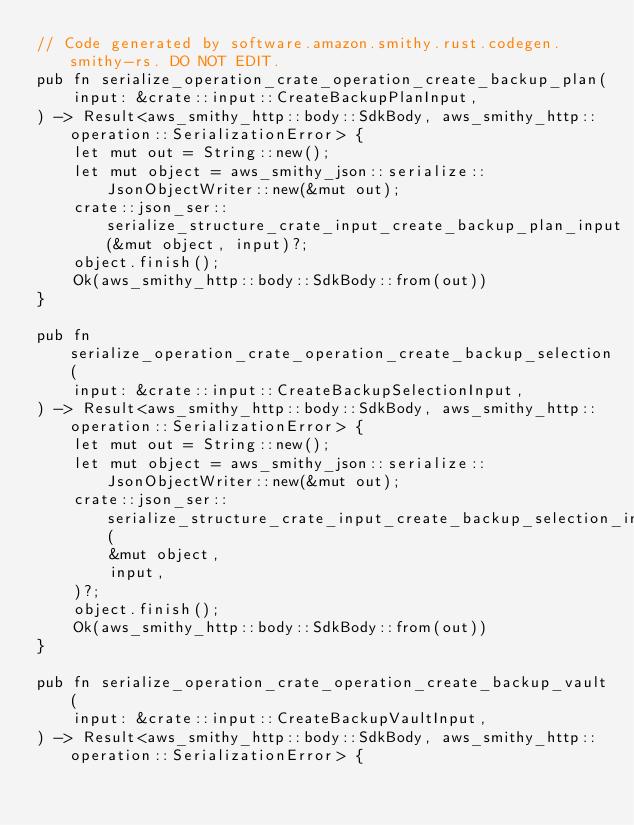<code> <loc_0><loc_0><loc_500><loc_500><_Rust_>// Code generated by software.amazon.smithy.rust.codegen.smithy-rs. DO NOT EDIT.
pub fn serialize_operation_crate_operation_create_backup_plan(
    input: &crate::input::CreateBackupPlanInput,
) -> Result<aws_smithy_http::body::SdkBody, aws_smithy_http::operation::SerializationError> {
    let mut out = String::new();
    let mut object = aws_smithy_json::serialize::JsonObjectWriter::new(&mut out);
    crate::json_ser::serialize_structure_crate_input_create_backup_plan_input(&mut object, input)?;
    object.finish();
    Ok(aws_smithy_http::body::SdkBody::from(out))
}

pub fn serialize_operation_crate_operation_create_backup_selection(
    input: &crate::input::CreateBackupSelectionInput,
) -> Result<aws_smithy_http::body::SdkBody, aws_smithy_http::operation::SerializationError> {
    let mut out = String::new();
    let mut object = aws_smithy_json::serialize::JsonObjectWriter::new(&mut out);
    crate::json_ser::serialize_structure_crate_input_create_backup_selection_input(
        &mut object,
        input,
    )?;
    object.finish();
    Ok(aws_smithy_http::body::SdkBody::from(out))
}

pub fn serialize_operation_crate_operation_create_backup_vault(
    input: &crate::input::CreateBackupVaultInput,
) -> Result<aws_smithy_http::body::SdkBody, aws_smithy_http::operation::SerializationError> {</code> 